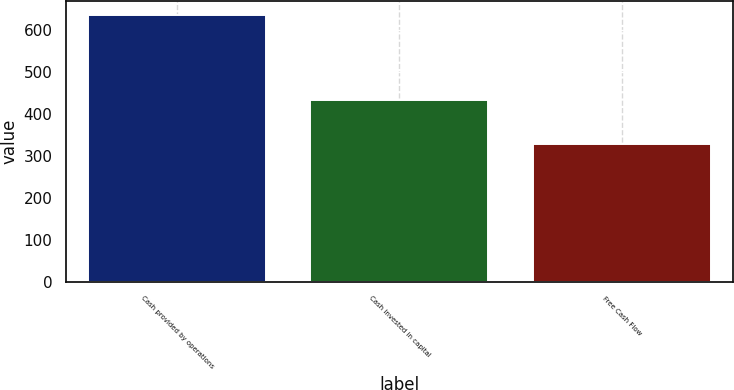Convert chart. <chart><loc_0><loc_0><loc_500><loc_500><bar_chart><fcel>Cash provided by operations<fcel>Cash invested in capital<fcel>Free Cash Flow<nl><fcel>637<fcel>434<fcel>328<nl></chart> 